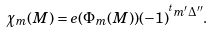Convert formula to latex. <formula><loc_0><loc_0><loc_500><loc_500>\chi _ { m } ( M ) = e ( \Phi _ { m } ( M ) ) ( - 1 ) ^ { ^ { t } m ^ { \prime } \Delta ^ { \prime \prime } } .</formula> 